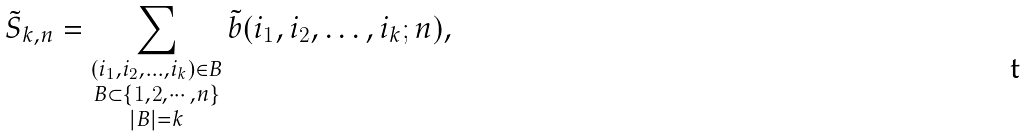Convert formula to latex. <formula><loc_0><loc_0><loc_500><loc_500>\tilde { S } _ { k , n } = \sum _ { \substack { ( i _ { 1 } , i _ { 2 } , \dots , i _ { k } ) \in B \\ B \subset \{ 1 , 2 , \cdots , n \} \\ | B | = k } } \tilde { b } ( i _ { 1 } , i _ { 2 } , \dots , i _ { k } ; n ) ,</formula> 